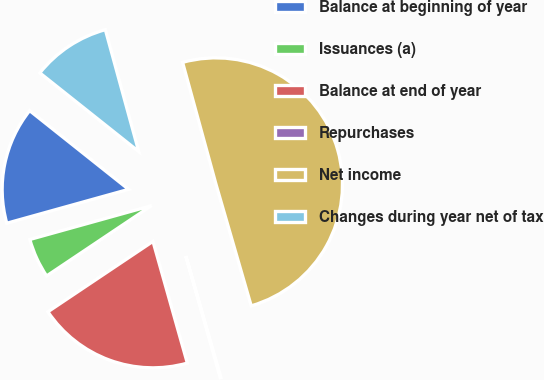Convert chart to OTSL. <chart><loc_0><loc_0><loc_500><loc_500><pie_chart><fcel>Balance at beginning of year<fcel>Issuances (a)<fcel>Balance at end of year<fcel>Repurchases<fcel>Net income<fcel>Changes during year net of tax<nl><fcel>15.01%<fcel>5.08%<fcel>19.98%<fcel>0.11%<fcel>49.77%<fcel>10.05%<nl></chart> 